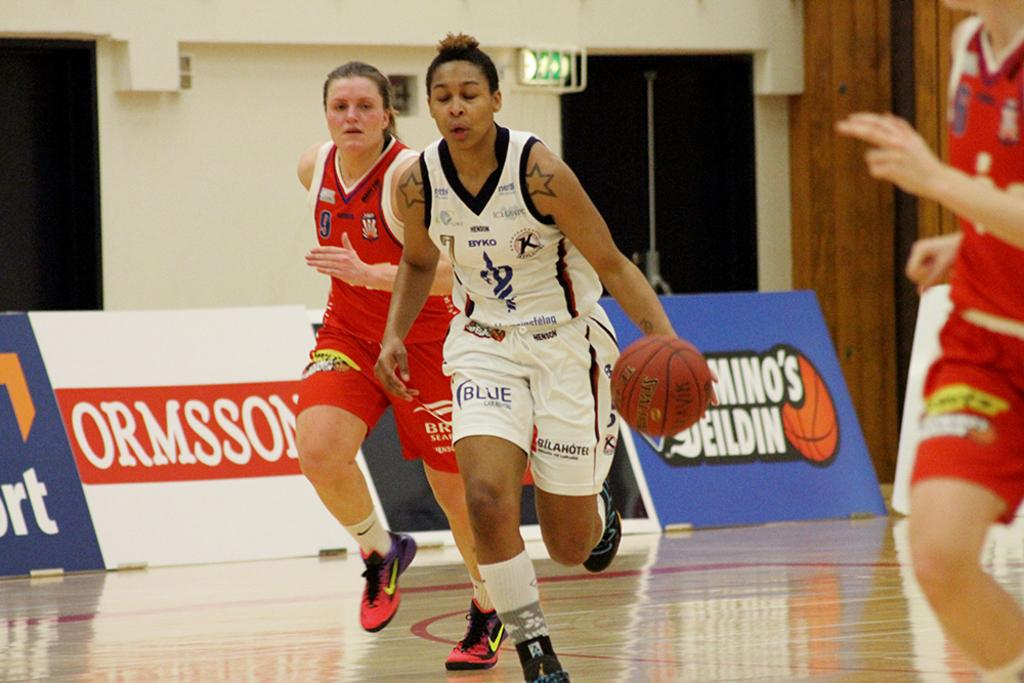Provide a one-sentence caption for the provided image. Number 7 dribbles the ball upcourt as number 9 on the other team tries to keep up. 